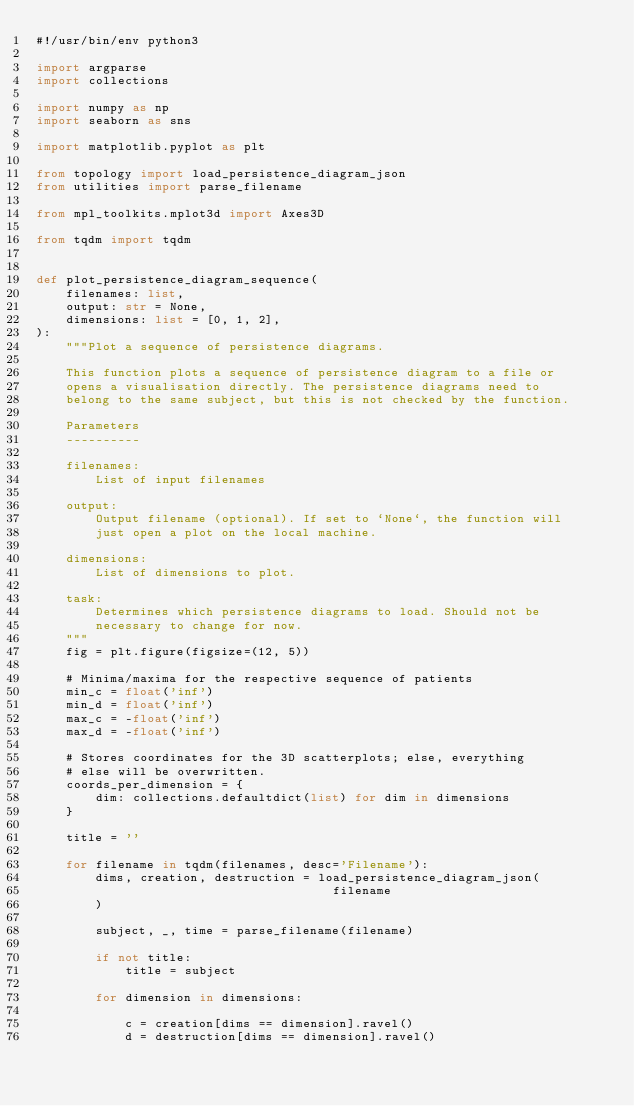<code> <loc_0><loc_0><loc_500><loc_500><_Python_>#!/usr/bin/env python3

import argparse
import collections

import numpy as np
import seaborn as sns

import matplotlib.pyplot as plt

from topology import load_persistence_diagram_json
from utilities import parse_filename

from mpl_toolkits.mplot3d import Axes3D

from tqdm import tqdm


def plot_persistence_diagram_sequence(
    filenames: list,
    output: str = None,
    dimensions: list = [0, 1, 2],
):
    """Plot a sequence of persistence diagrams.

    This function plots a sequence of persistence diagram to a file or
    opens a visualisation directly. The persistence diagrams need to
    belong to the same subject, but this is not checked by the function.

    Parameters
    ----------

    filenames:
        List of input filenames

    output:
        Output filename (optional). If set to `None`, the function will
        just open a plot on the local machine.

    dimensions:
        List of dimensions to plot.

    task:
        Determines which persistence diagrams to load. Should not be
        necessary to change for now.
    """
    fig = plt.figure(figsize=(12, 5))

    # Minima/maxima for the respective sequence of patients
    min_c = float('inf')
    min_d = float('inf')
    max_c = -float('inf')
    max_d = -float('inf')

    # Stores coordinates for the 3D scatterplots; else, everything
    # else will be overwritten.
    coords_per_dimension = {
        dim: collections.defaultdict(list) for dim in dimensions
    }

    title = ''

    for filename in tqdm(filenames, desc='Filename'):
        dims, creation, destruction = load_persistence_diagram_json(
                                        filename
        )

        subject, _, time = parse_filename(filename)

        if not title:
            title = subject

        for dimension in dimensions:

            c = creation[dims == dimension].ravel()
            d = destruction[dims == dimension].ravel()</code> 